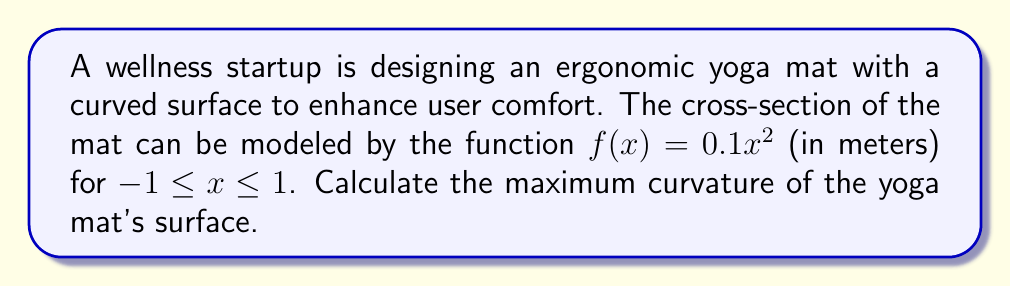Help me with this question. To find the maximum curvature of the yoga mat's surface, we'll follow these steps:

1) The curvature κ of a curve $y = f(x)$ is given by:

   $$\kappa = \frac{|f''(x)|}{(1 + [f'(x)]^2)^{3/2}}$$

2) First, let's find $f'(x)$ and $f''(x)$:
   
   $f(x) = 0.1x^2$
   $f'(x) = 0.2x$
   $f''(x) = 0.2$

3) Now, we can substitute these into the curvature formula:

   $$\kappa = \frac{|0.2|}{(1 + [0.2x]^2)^{3/2}}$$

4) To find the maximum curvature, we need to minimize the denominator. The denominator will be smallest when $x = 0$, as this makes the $[0.2x]^2$ term zero.

5) Therefore, the maximum curvature occurs at $x = 0$:

   $$\kappa_{max} = \frac{|0.2|}{(1 + [0]^2)^{3/2}} = 0.2$$

6) The units of curvature are reciprocal meters (m^-1).
Answer: 0.2 m^-1 